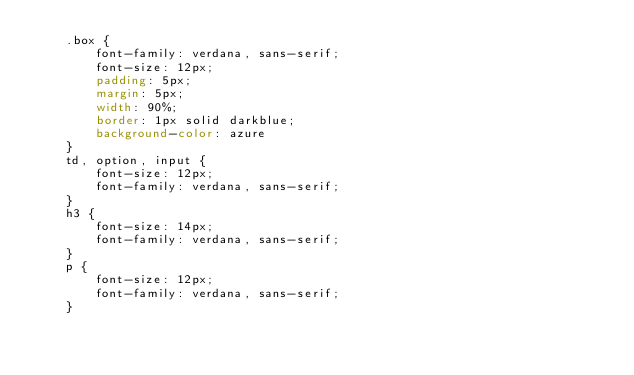<code> <loc_0><loc_0><loc_500><loc_500><_CSS_>    .box {
        font-family: verdana, sans-serif; 
        font-size: 12px;
        padding: 5px;
        margin: 5px;
        width: 90%;
        border: 1px solid darkblue;
        background-color: azure
    }
    td, option, input {
        font-size: 12px;
        font-family: verdana, sans-serif;
    }
    h3 {
        font-size: 14px;
        font-family: verdana, sans-serif;
    }
    p {
        font-size: 12px;
        font-family: verdana, sans-serif;
    }</code> 